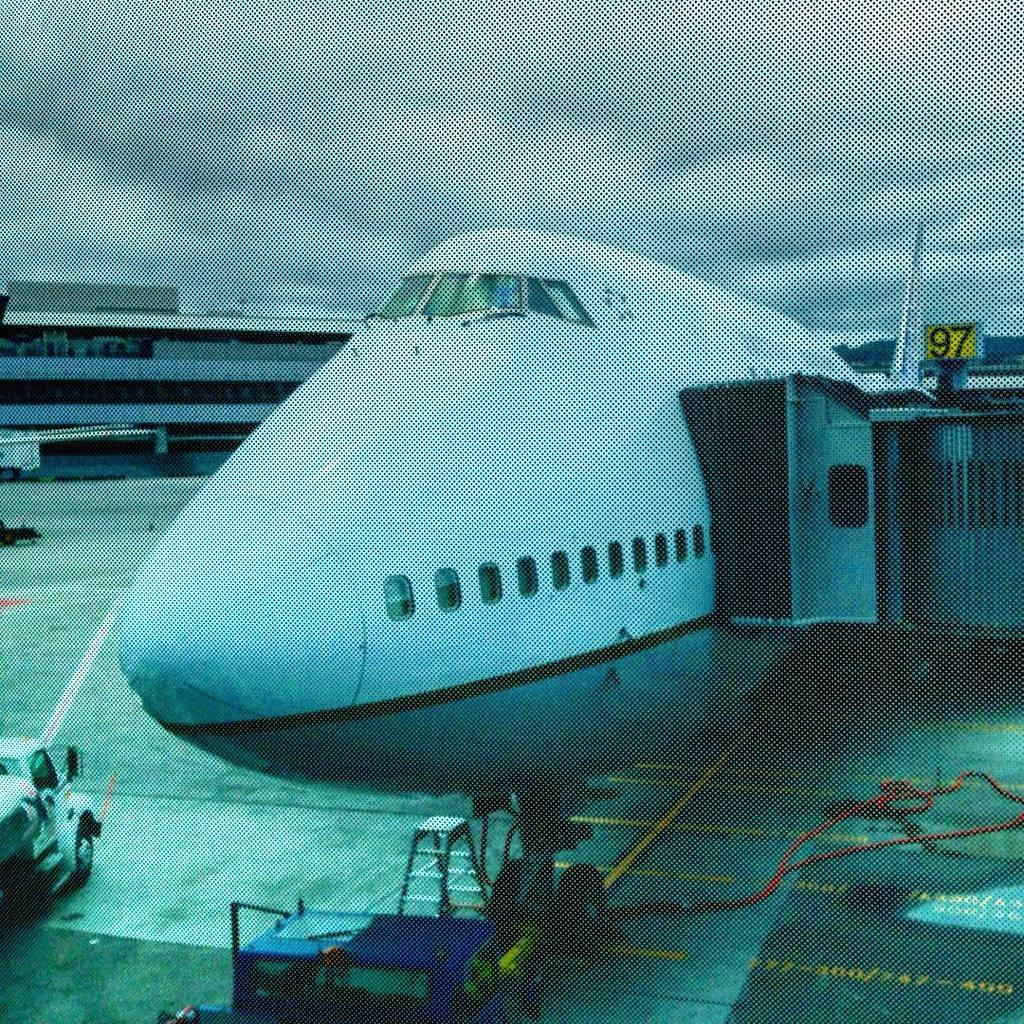<image>
Create a compact narrative representing the image presented. An airplane sits in an airport at gate 97 for boarding. 